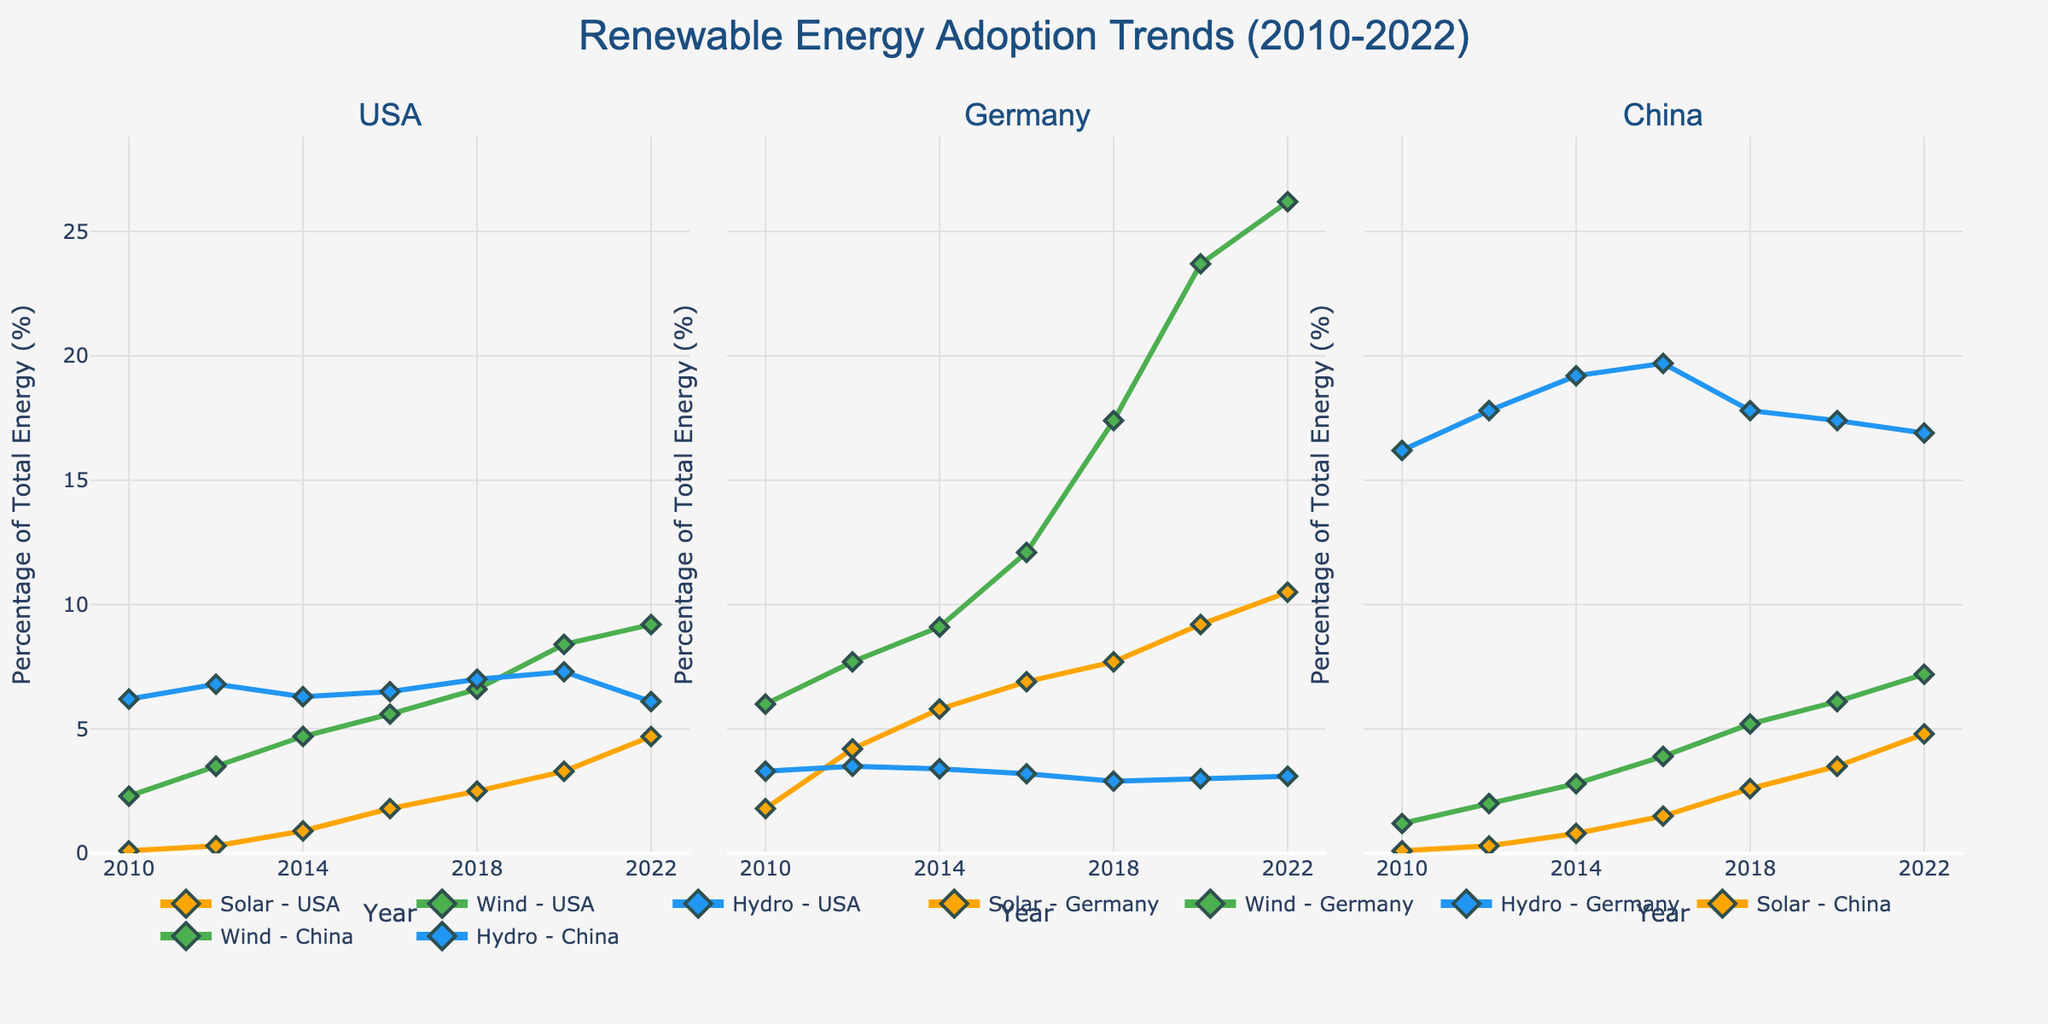basic question The figure's title is located at the top center, and it clearly indicates what the plot represents. The legend, showing different regions with distinct colors and symbols, helps identify data points. The axes are labeled according to customer satisfaction, delivery time, product availability, and return rate.
Answer: E-commerce Operations Performance Matrix How many data points are plotted in the Northeast region? You look for the data points in the scatterplot matrix that are colored and symbolized as the Northeast region. Count those data points in the matrix.
Answer: One Which axis represents delivery time? You look at the axis labels of the scatterplot matrix to identify the one labeled "Delivery Time (days)."
Answer: The x-axis What is the general correlation between customer satisfaction and delivery time? You observe the scatterplot for customer satisfaction and delivery time across all regions. If the points trend downwards as delivery time increases, it suggests a negative correlation.
Answer: Negative correlation Which region has the highest customer satisfaction given the plotted data? Looking at the scatterplot matrix, you find the region with the highest value in the customer satisfaction axis.
Answer: Midwest How does product availability in the Southeast compare to that in the Central region? Look at the points corresponding to the Southeast and Central regions concerning product availability. Compare the numerical values indicated on the product availability axis.
Answer: Southeast has higher availability What is the return rate comparison between the Southwest and New England regions? Observe the points corresponding to Southwest and New England in the scatterplot matrix. Compare their values along the return rate axis.
Answer: Southwest has a higher return rate Is there any region where high product availability correlates with low return rates? Search for points representing regions where high product availability aligns with low return rates. Check if the trend is generally true for specific regions or data points.
Answer: Midwest, NewEngland What is the average customer satisfaction score across all regions? Sum all customer satisfaction scores provided for the regions and divide by the total number of regions (10).
Answer: 8.1 Which region has the shortest delivery time? Find the region with the lowest value on the delivery time axis.
Answer: Midwest 